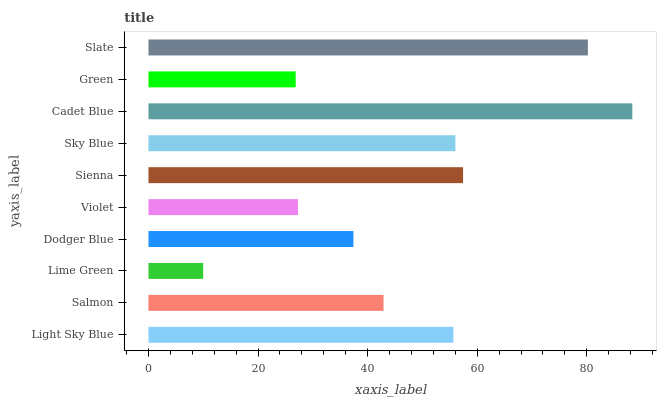Is Lime Green the minimum?
Answer yes or no. Yes. Is Cadet Blue the maximum?
Answer yes or no. Yes. Is Salmon the minimum?
Answer yes or no. No. Is Salmon the maximum?
Answer yes or no. No. Is Light Sky Blue greater than Salmon?
Answer yes or no. Yes. Is Salmon less than Light Sky Blue?
Answer yes or no. Yes. Is Salmon greater than Light Sky Blue?
Answer yes or no. No. Is Light Sky Blue less than Salmon?
Answer yes or no. No. Is Light Sky Blue the high median?
Answer yes or no. Yes. Is Salmon the low median?
Answer yes or no. Yes. Is Dodger Blue the high median?
Answer yes or no. No. Is Violet the low median?
Answer yes or no. No. 